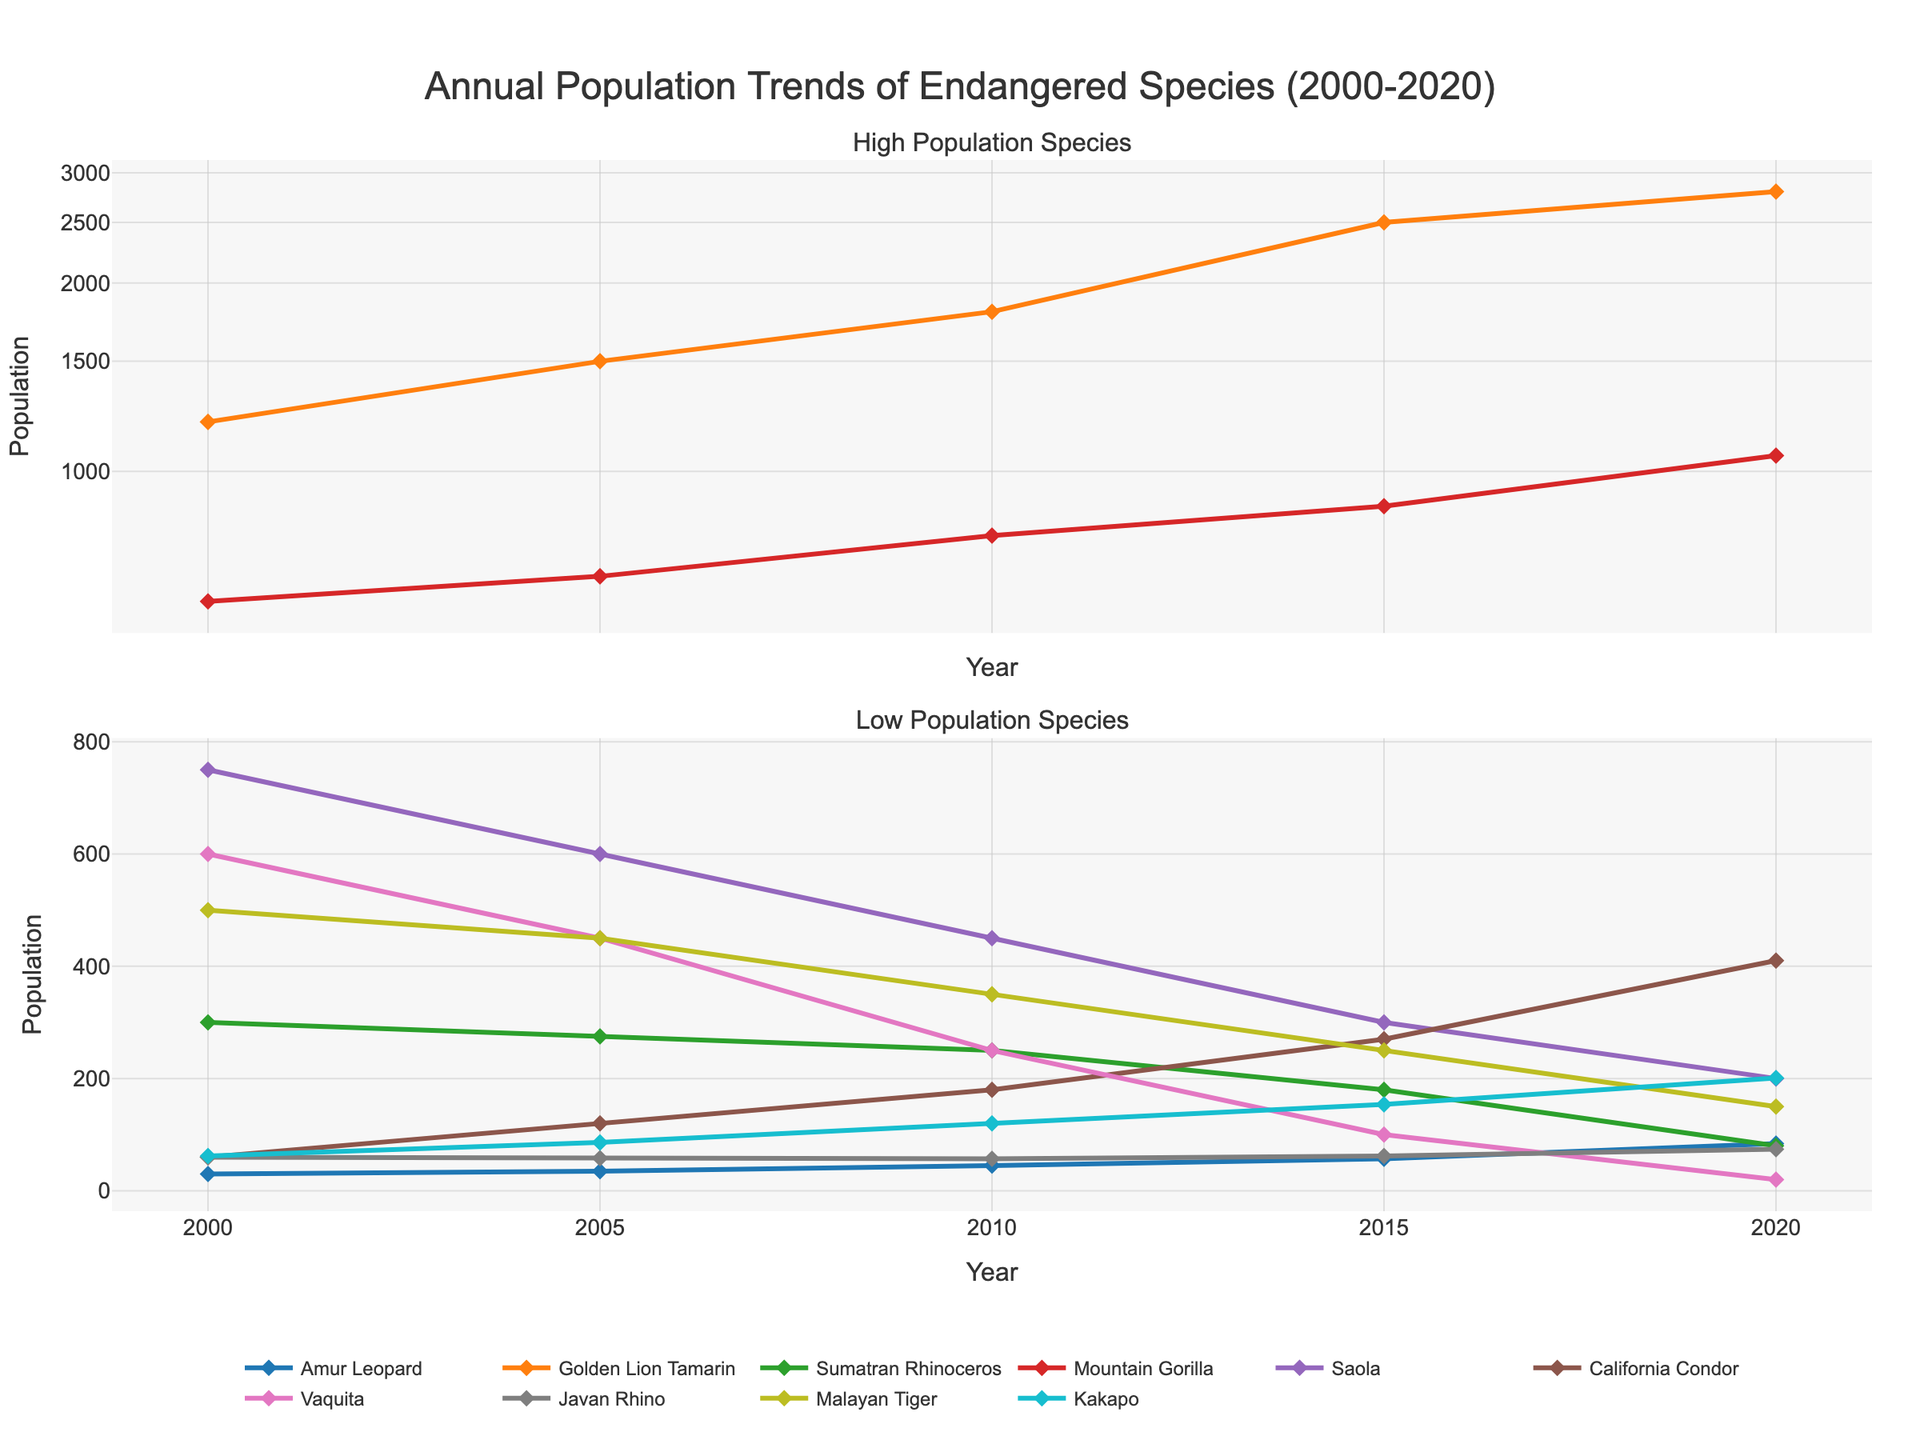What's the population trend for the Amur Leopard from 2000 to 2020? The line for the Amur Leopard shows an upward trend over the years. Starting from 30 in 2000, it steadily increases to 35, 45, 57 and reaches 84 in 2020.
Answer: Increasing Which species has the most significant population decline from 2000 to 2020? By comparing the starting and ending populations of each species, the Vaquita shows the sharpest decline. It starts from 600 in 2000 and decreases continuously to only 20 in 2020.
Answer: Vaquita How many species have a population of over 1000 at any point between 2000 and 2020? By checking each species' population data, the Golden Lion Tamarin and Mountain Gorilla both surpass 1000 at some point.
Answer: 2 Which species shows a recovery in population towards the end of the period after an initial decline? The population count of the Javan Rhino increases from 60 in 2000 to 58 in 2005, then it slightly fluctuates and recovers to 74 in 2020.
Answer: Javan Rhino Compare the population of the California Condor in 2000 and 2020. The population of the California Condor starts at 60 in 2000 and increases significantly to 410 in 2020, indicating a positive recovery trend.
Answer: 60 in 2000, 410 in 2020 Which species had a population of less than 100 in 2020? From the 2020 data, the Sumatran Rhinoceros (80) and Vaquita (20) have populations below 100.
Answer: Sumatran Rhinoceros, Vaquita What is the average population of the Kakapo over the two decades? The population points for the Kakapo are 62, 86, 120, 154, and 201. The average is calculated as (62 + 86 + 120 + 154 + 201) / 5 = 124.6.
Answer: 124.6 In which year does the Mountain Gorilla first surpass a population of 1000? Observing the population trend, the Mountain Gorilla surpasses 1000 in 2020, reaching 1060.
Answer: 2020 How does the Sumatran Rhinoceros population change from 2000 to 2020? The Sumatran Rhinoceros population declines from 300 in 2000 to 80 in 2020, showing a consistent downward trend.
Answer: Decreasing 